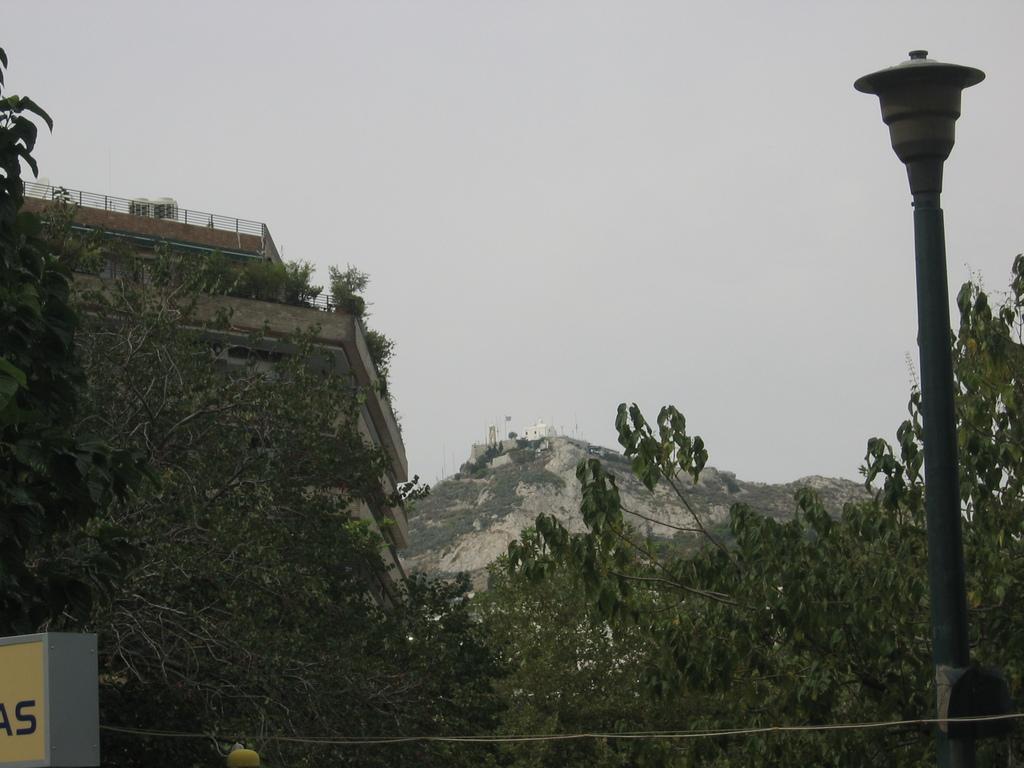How would you summarize this image in a sentence or two? In this image I see a building over here and I see number of trees and I see a pole over here and I see 2 alphabets written on this yellow and white color thing. In the background I see the sky and I see the rocky mountain over here. 